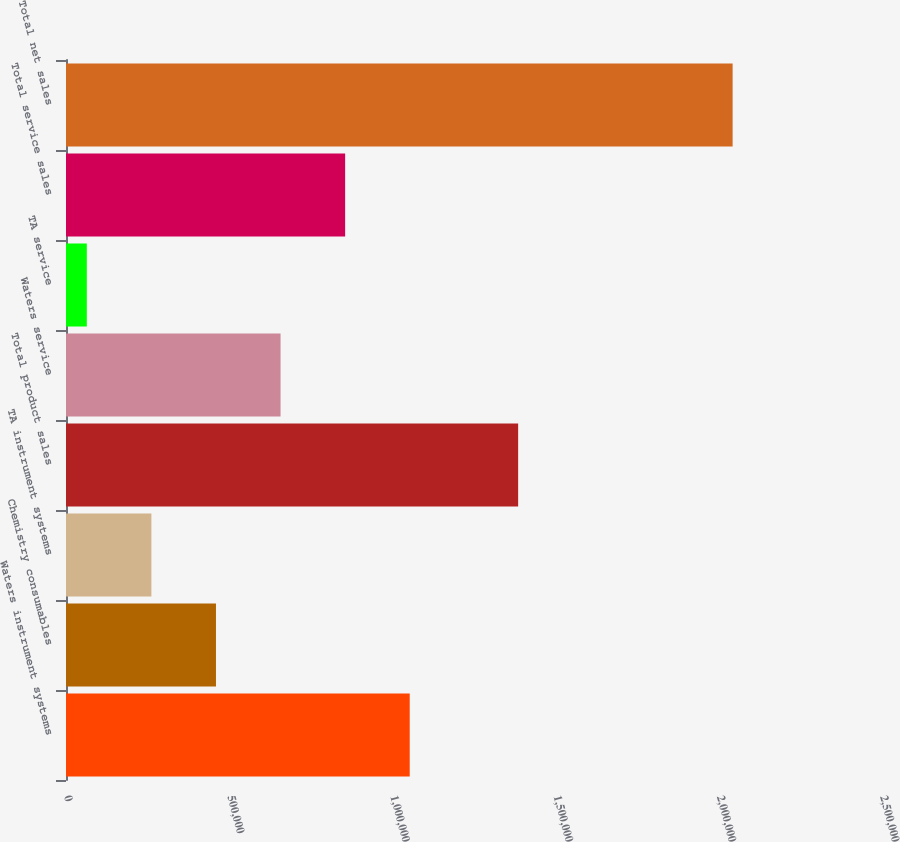Convert chart to OTSL. <chart><loc_0><loc_0><loc_500><loc_500><bar_chart><fcel>Waters instrument systems<fcel>Chemistry consumables<fcel>TA instrument systems<fcel>Total product sales<fcel>Waters service<fcel>TA service<fcel>Total service sales<fcel>Total net sales<nl><fcel>1.05305e+06<fcel>459486<fcel>261631<fcel>1.38526e+06<fcel>657342<fcel>63775<fcel>855198<fcel>2.04233e+06<nl></chart> 